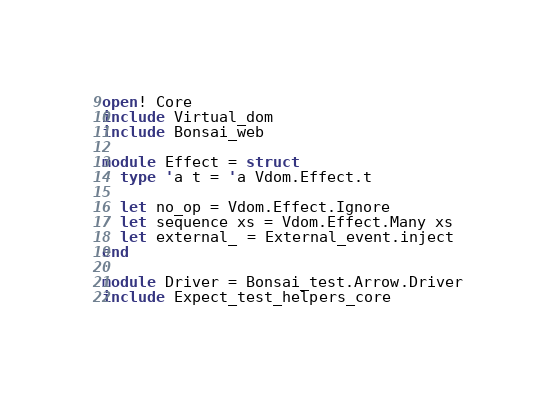<code> <loc_0><loc_0><loc_500><loc_500><_OCaml_>open! Core
include Virtual_dom
include Bonsai_web

module Effect = struct
  type 'a t = 'a Vdom.Effect.t

  let no_op = Vdom.Effect.Ignore
  let sequence xs = Vdom.Effect.Many xs
  let external_ = External_event.inject
end

module Driver = Bonsai_test.Arrow.Driver
include Expect_test_helpers_core
</code> 